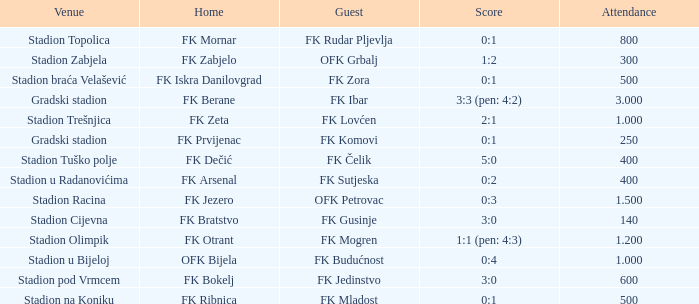What was the score for the game with FK Bratstvo as home team? 3:0. 